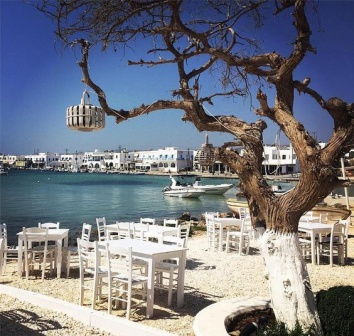If this place could tell a story, what would it say? If this place could tell a story, it would be the tale of countless sunsets witnessed and many shared memories. It would speak of the laughter of families and friends enjoying sumptuous meals, the whispered conversations of lovers under the moonlit sky, and the jubilant celebrations of weddings and anniversaries. It would recount the hard work of the local fishermen who bring in the fresh catch every morning, the dedicated chefs who transform these treasures into culinary delights, and the servers who craft lasting impressions with their warm smiles. This place is a haven of relaxation and connection, a spot where time seemingly stands still allowing people to savor the beauty of life by the sea. 